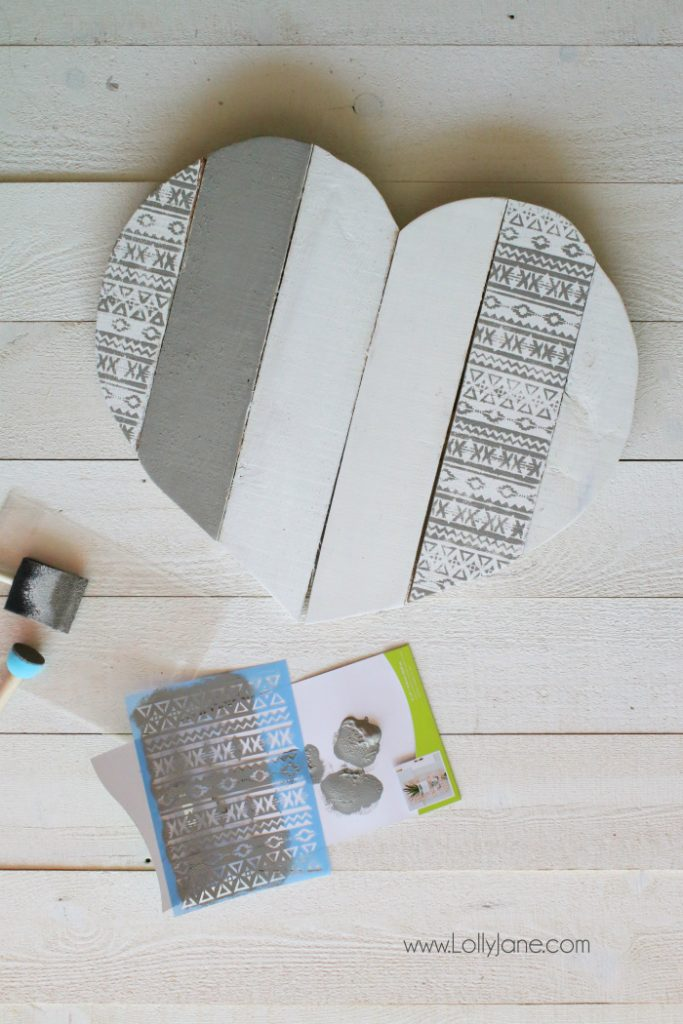How might the creator ensure that the paint does not seep under the stencil when creating the pattern? To ensure that the paint does not seep under the stencil when creating the pattern, the creator needs to follow a few careful steps. First, they should securely affix the stencil to the wooden surface using painter's tape or a temporary adhesive spray to prevent any movement. The paint roller or brush should have just enough paint to cover the stencil without being overly saturated; excess paint can cause bleeding at the edges of the stencil. The creator should apply the paint with light, even pressure, working from the edges inward to minimize the risk of seepage. They can also use stencil brushes which are designed to hold less paint than regular brushes, making them ideal for this purpose. Allowing each layer of paint to dry fully before removing the stencil also helps in achieving crisp, clean lines. Finally, carefully peeling off the stencil after the paint has dried aids in maintaining the sharpness of the design. What kind of paint works best for this type of stencil work on wood? For stencil work on wood, using acrylic paint is generally the best choice. Acrylic paints are water-based, making them easy to clean up, and they dry quickly, which helps in the layering process. They also adhere well to wood surfaces and come in a wide variety of colors and finishes, from matte to gloss. Some specialty acrylic paints are designed specifically for crafting and offer durability suitable for items that may endure wear, such as decor pieces or furniture. Chalk paint could also be a good option; it adheres superbly to wood and gives a unique, vintage finish. Both acrylic and chalk paints provide the versatility and ease of use needed for detailed stencil work. Why might the geometric pattern be appealing for home decor? Geometric patterns have a timeless appeal in home decor for several reasons. Firstly, their structured and symmetrical nature creates a sense of order and balance, which can be visually calming and pleasing. These patterns can act as a neutral yet sophisticated design element that complements a variety of interior styles, from modern and minimalist to eclectic and boho. Additionally, geometric patterns can be both bold and subtle, making them versatile for different purposes—whether as a focal point or as an accent. They also resonate with the human brain's preference for patterns and symmetry, making them instinctively attractive. By incorporating geometric designs, spaces can feel more dynamic and energized while maintaining a harmonious aesthetic. 